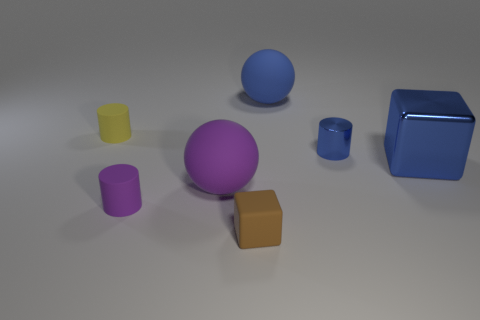Subtract all matte cylinders. How many cylinders are left? 1 Subtract all blue cylinders. How many cylinders are left? 2 Subtract all balls. How many objects are left? 5 Add 2 small yellow matte cylinders. How many objects exist? 9 Subtract 1 cylinders. How many cylinders are left? 2 Subtract 0 gray blocks. How many objects are left? 7 Subtract all yellow cubes. Subtract all green spheres. How many cubes are left? 2 Subtract all brown cylinders. How many red balls are left? 0 Subtract all tiny brown rubber things. Subtract all tiny cylinders. How many objects are left? 3 Add 2 small blue shiny cylinders. How many small blue shiny cylinders are left? 3 